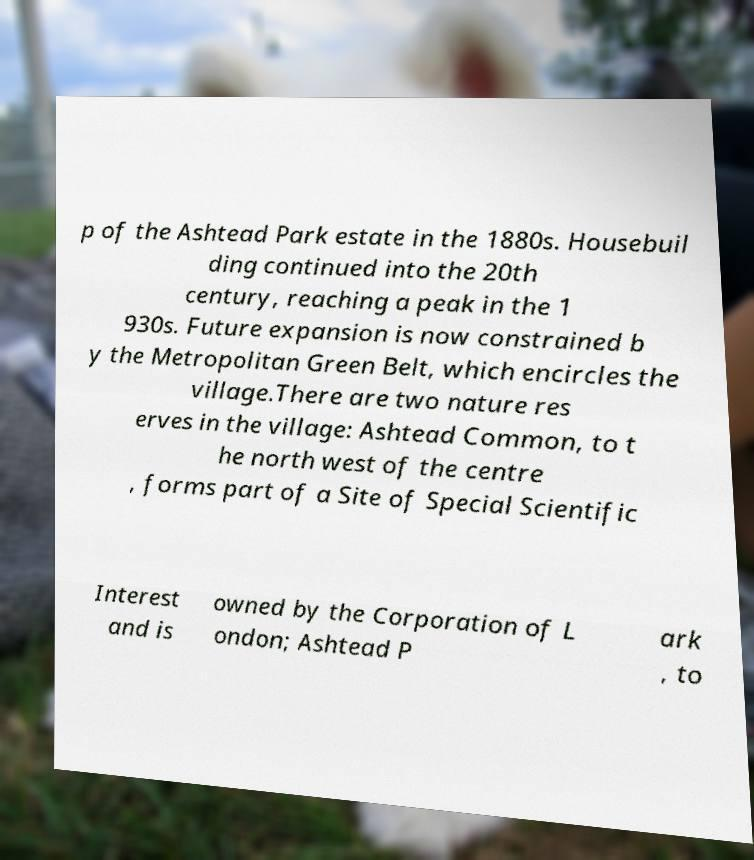Could you extract and type out the text from this image? p of the Ashtead Park estate in the 1880s. Housebuil ding continued into the 20th century, reaching a peak in the 1 930s. Future expansion is now constrained b y the Metropolitan Green Belt, which encircles the village.There are two nature res erves in the village: Ashtead Common, to t he north west of the centre , forms part of a Site of Special Scientific Interest and is owned by the Corporation of L ondon; Ashtead P ark , to 